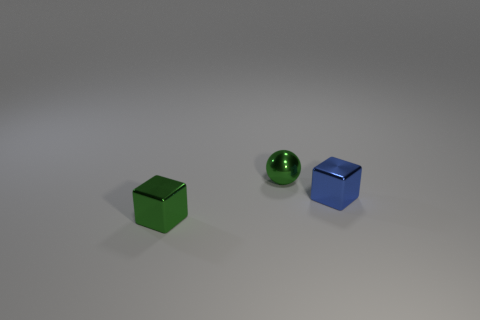Subtract all gray cubes. Subtract all blue cylinders. How many cubes are left? 2 Add 3 green objects. How many objects exist? 6 Subtract all spheres. How many objects are left? 2 Subtract all small red metal balls. Subtract all spheres. How many objects are left? 2 Add 3 tiny metal things. How many tiny metal things are left? 6 Add 1 cyan cubes. How many cyan cubes exist? 1 Subtract 0 purple cylinders. How many objects are left? 3 